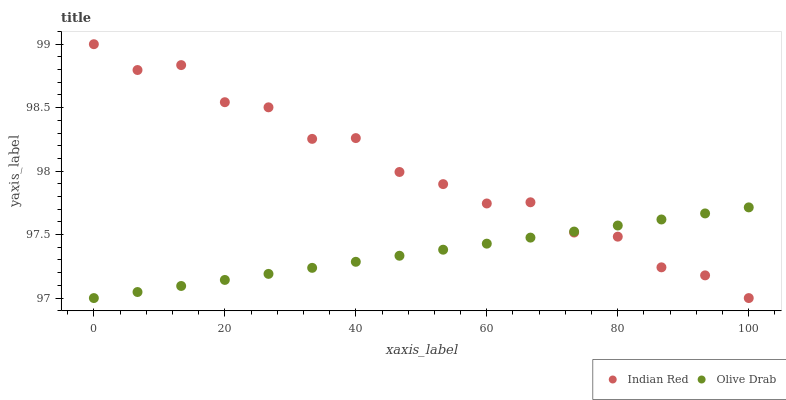Does Olive Drab have the minimum area under the curve?
Answer yes or no. Yes. Does Indian Red have the maximum area under the curve?
Answer yes or no. Yes. Does Indian Red have the minimum area under the curve?
Answer yes or no. No. Is Olive Drab the smoothest?
Answer yes or no. Yes. Is Indian Red the roughest?
Answer yes or no. Yes. Is Indian Red the smoothest?
Answer yes or no. No. Does Olive Drab have the lowest value?
Answer yes or no. Yes. Does Indian Red have the highest value?
Answer yes or no. Yes. Does Olive Drab intersect Indian Red?
Answer yes or no. Yes. Is Olive Drab less than Indian Red?
Answer yes or no. No. Is Olive Drab greater than Indian Red?
Answer yes or no. No. 